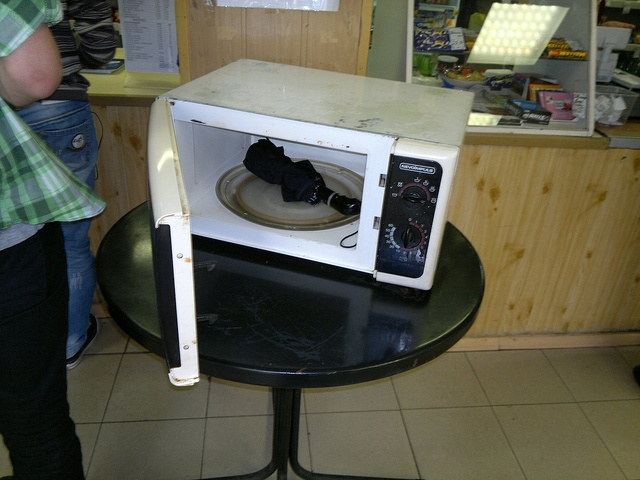Describe the objects in this image and their specific colors. I can see microwave in teal, darkgray, lavender, black, and gray tones, people in darkgreen, black, gray, and teal tones, people in teal, black, navy, blue, and purple tones, and umbrella in teal, black, gray, and darkgray tones in this image. 